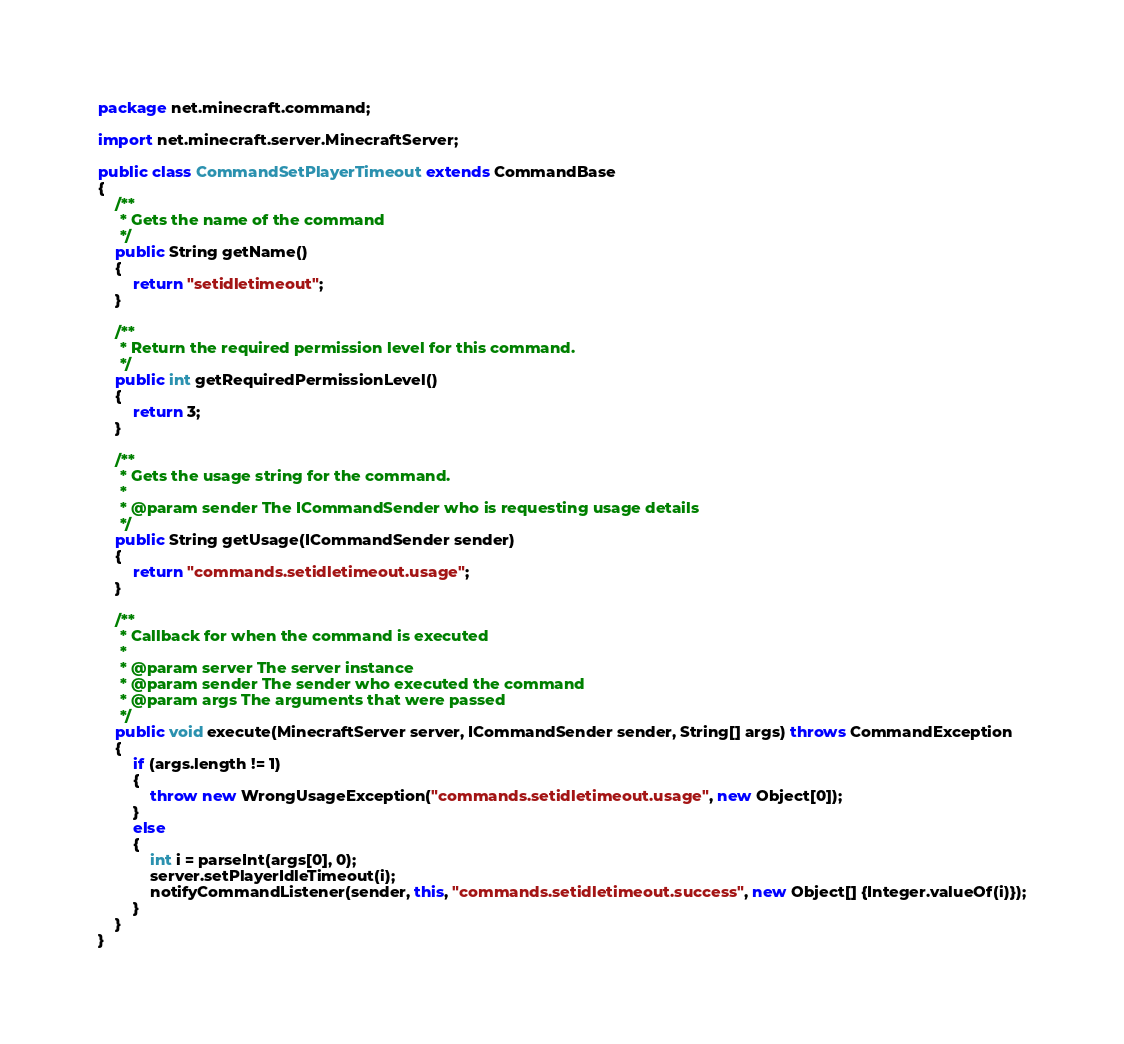<code> <loc_0><loc_0><loc_500><loc_500><_Java_>package net.minecraft.command;

import net.minecraft.server.MinecraftServer;

public class CommandSetPlayerTimeout extends CommandBase
{
    /**
     * Gets the name of the command
     */
    public String getName()
    {
        return "setidletimeout";
    }

    /**
     * Return the required permission level for this command.
     */
    public int getRequiredPermissionLevel()
    {
        return 3;
    }

    /**
     * Gets the usage string for the command.
     *  
     * @param sender The ICommandSender who is requesting usage details
     */
    public String getUsage(ICommandSender sender)
    {
        return "commands.setidletimeout.usage";
    }

    /**
     * Callback for when the command is executed
     *  
     * @param server The server instance
     * @param sender The sender who executed the command
     * @param args The arguments that were passed
     */
    public void execute(MinecraftServer server, ICommandSender sender, String[] args) throws CommandException
    {
        if (args.length != 1)
        {
            throw new WrongUsageException("commands.setidletimeout.usage", new Object[0]);
        }
        else
        {
            int i = parseInt(args[0], 0);
            server.setPlayerIdleTimeout(i);
            notifyCommandListener(sender, this, "commands.setidletimeout.success", new Object[] {Integer.valueOf(i)});
        }
    }
}</code> 